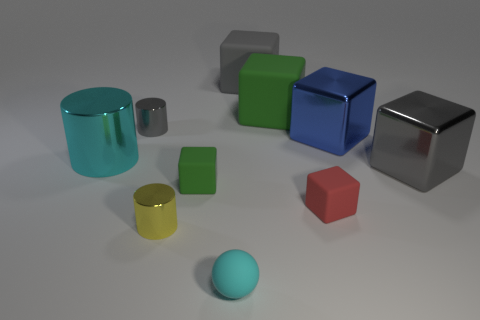What is the material of the large object that is the same color as the ball?
Your answer should be compact. Metal. Is the color of the small matte ball the same as the large shiny thing on the left side of the small red rubber block?
Offer a terse response. Yes. What is the color of the cube left of the cyan rubber ball on the left side of the small rubber thing that is right of the cyan ball?
Offer a very short reply. Green. Do the big cyan shiny object and the green matte thing that is to the left of the matte ball have the same shape?
Offer a very short reply. No. What color is the rubber block that is behind the tiny green rubber cube and in front of the big gray matte thing?
Make the answer very short. Green. Is there a big gray shiny thing of the same shape as the cyan rubber thing?
Your answer should be compact. No. Does the rubber ball have the same color as the big cylinder?
Your response must be concise. Yes. There is a tiny cube right of the small cyan sphere; are there any gray blocks that are on the left side of it?
Give a very brief answer. Yes. What number of things are either tiny cylinders in front of the red cube or large objects that are to the right of the big blue metal thing?
Give a very brief answer. 2. What number of things are either large rubber objects or cylinders that are to the right of the big cyan cylinder?
Keep it short and to the point. 4. 